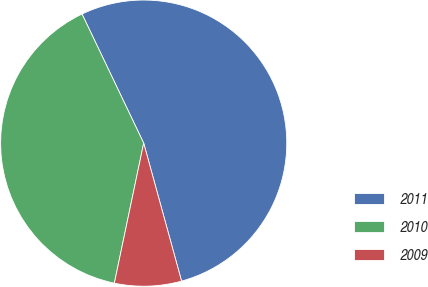Convert chart. <chart><loc_0><loc_0><loc_500><loc_500><pie_chart><fcel>2011<fcel>2010<fcel>2009<nl><fcel>52.83%<fcel>39.62%<fcel>7.55%<nl></chart> 